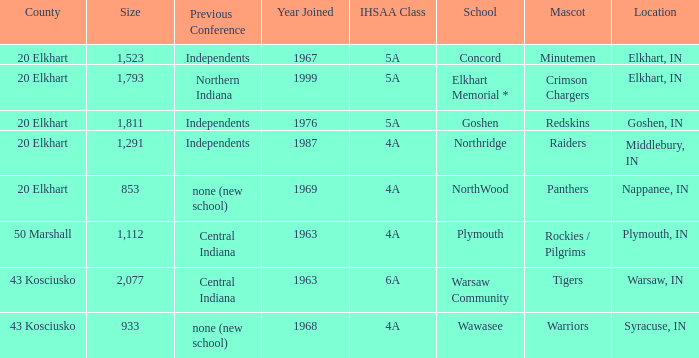What is the IHSAA class for the team located in Middlebury, IN? 4A. 